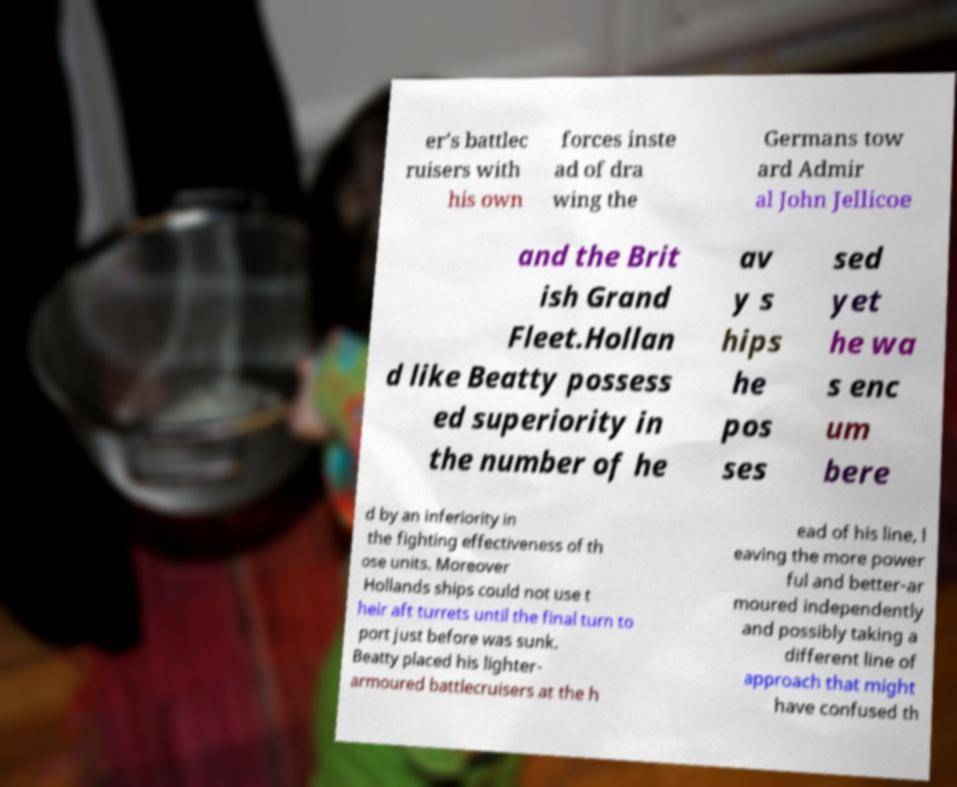What messages or text are displayed in this image? I need them in a readable, typed format. er's battlec ruisers with his own forces inste ad of dra wing the Germans tow ard Admir al John Jellicoe and the Brit ish Grand Fleet.Hollan d like Beatty possess ed superiority in the number of he av y s hips he pos ses sed yet he wa s enc um bere d by an inferiority in the fighting effectiveness of th ose units. Moreover Hollands ships could not use t heir aft turrets until the final turn to port just before was sunk. Beatty placed his lighter- armoured battlecruisers at the h ead of his line, l eaving the more power ful and better-ar moured independently and possibly taking a different line of approach that might have confused th 